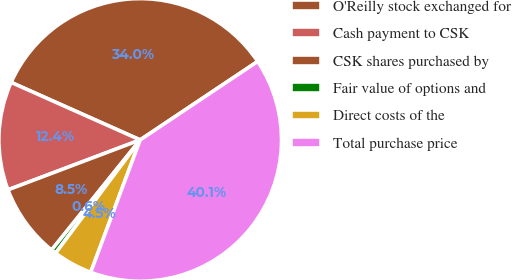Convert chart to OTSL. <chart><loc_0><loc_0><loc_500><loc_500><pie_chart><fcel>O'Reilly stock exchanged for<fcel>Cash payment to CSK<fcel>CSK shares purchased by<fcel>Fair value of options and<fcel>Direct costs of the<fcel>Total purchase price<nl><fcel>33.95%<fcel>12.42%<fcel>8.47%<fcel>0.57%<fcel>4.52%<fcel>40.06%<nl></chart> 